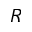<formula> <loc_0><loc_0><loc_500><loc_500>R</formula> 